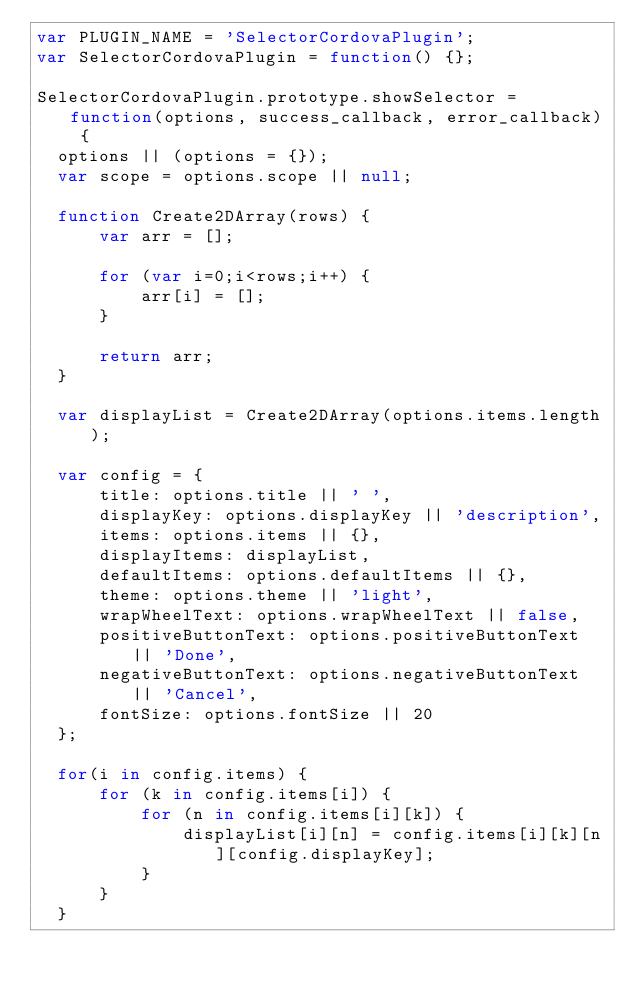Convert code to text. <code><loc_0><loc_0><loc_500><loc_500><_JavaScript_>var PLUGIN_NAME = 'SelectorCordovaPlugin';
var SelectorCordovaPlugin = function() {};

SelectorCordovaPlugin.prototype.showSelector = function(options, success_callback, error_callback) {
  options || (options = {});
  var scope = options.scope || null;

  function Create2DArray(rows) {
      var arr = [];

      for (var i=0;i<rows;i++) {
          arr[i] = [];
      }

      return arr;
  }

  var displayList = Create2DArray(options.items.length);

  var config = {
      title: options.title || ' ',
      displayKey: options.displayKey || 'description',
      items: options.items || {},
      displayItems: displayList,
      defaultItems: options.defaultItems || {},
      theme: options.theme || 'light',
      wrapWheelText: options.wrapWheelText || false,
      positiveButtonText: options.positiveButtonText || 'Done',
      negativeButtonText: options.negativeButtonText || 'Cancel',
      fontSize: options.fontSize || 20
  };

  for(i in config.items) {
      for (k in config.items[i]) {
          for (n in config.items[i][k]) {
              displayList[i][n] = config.items[i][k][n][config.displayKey];
          }
      }
  }
</code> 